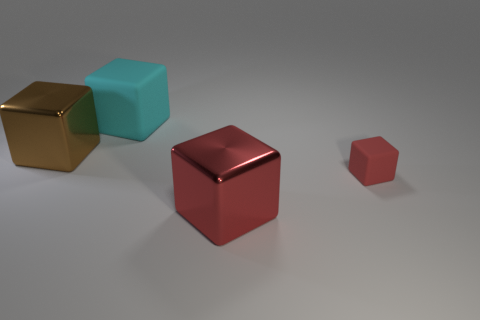Are there any other things that have the same size as the red matte thing?
Make the answer very short. No. How many rubber objects are tiny red cubes or big red objects?
Give a very brief answer. 1. Are any small red metallic spheres visible?
Keep it short and to the point. No. What color is the big shiny object behind the red object to the right of the large red cube?
Your response must be concise. Brown. What number of other objects are there of the same color as the tiny matte block?
Your response must be concise. 1. How many things are small brown things or cyan matte objects behind the small red rubber thing?
Give a very brief answer. 1. What is the color of the matte block behind the brown metal block?
Give a very brief answer. Cyan. The cyan object is what shape?
Keep it short and to the point. Cube. What is the material of the red cube that is behind the big shiny object that is to the right of the big cyan matte cube?
Provide a succinct answer. Rubber. How many other objects are the same material as the brown object?
Make the answer very short. 1. 